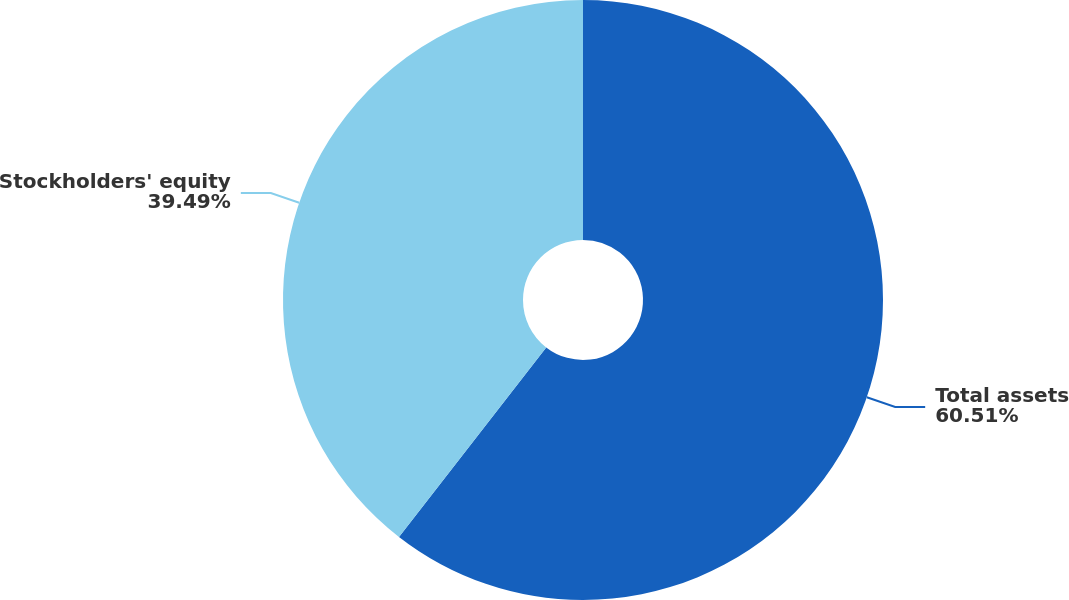Convert chart to OTSL. <chart><loc_0><loc_0><loc_500><loc_500><pie_chart><fcel>Total assets<fcel>Stockholders' equity<nl><fcel>60.51%<fcel>39.49%<nl></chart> 